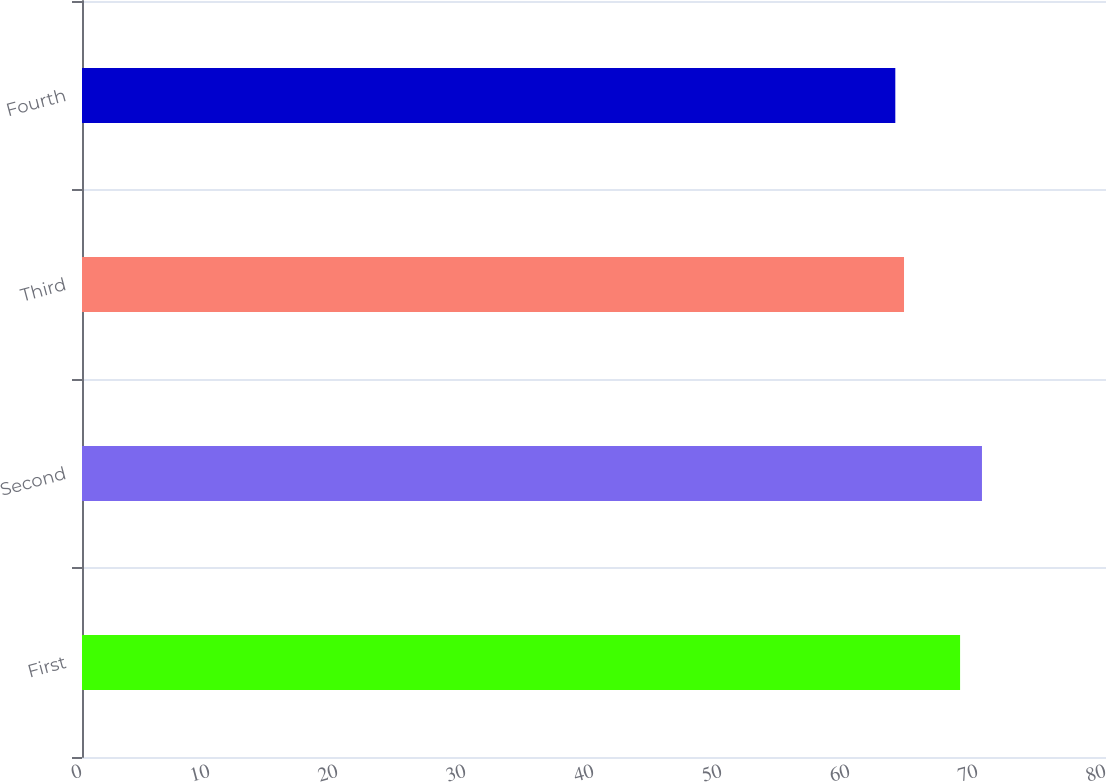<chart> <loc_0><loc_0><loc_500><loc_500><bar_chart><fcel>First<fcel>Second<fcel>Third<fcel>Fourth<nl><fcel>68.6<fcel>70.31<fcel>64.22<fcel>63.54<nl></chart> 